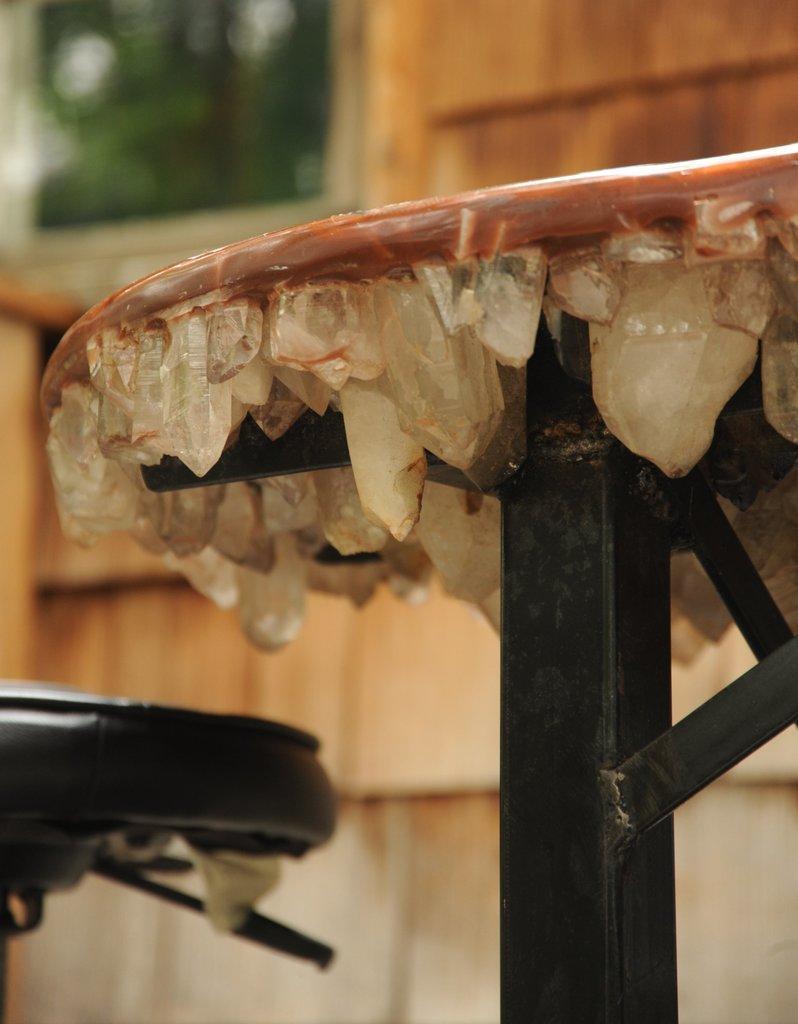Describe this image in one or two sentences. In the center of the image, we can see a stand and there is another object. In the background, there is a wall and a window. 